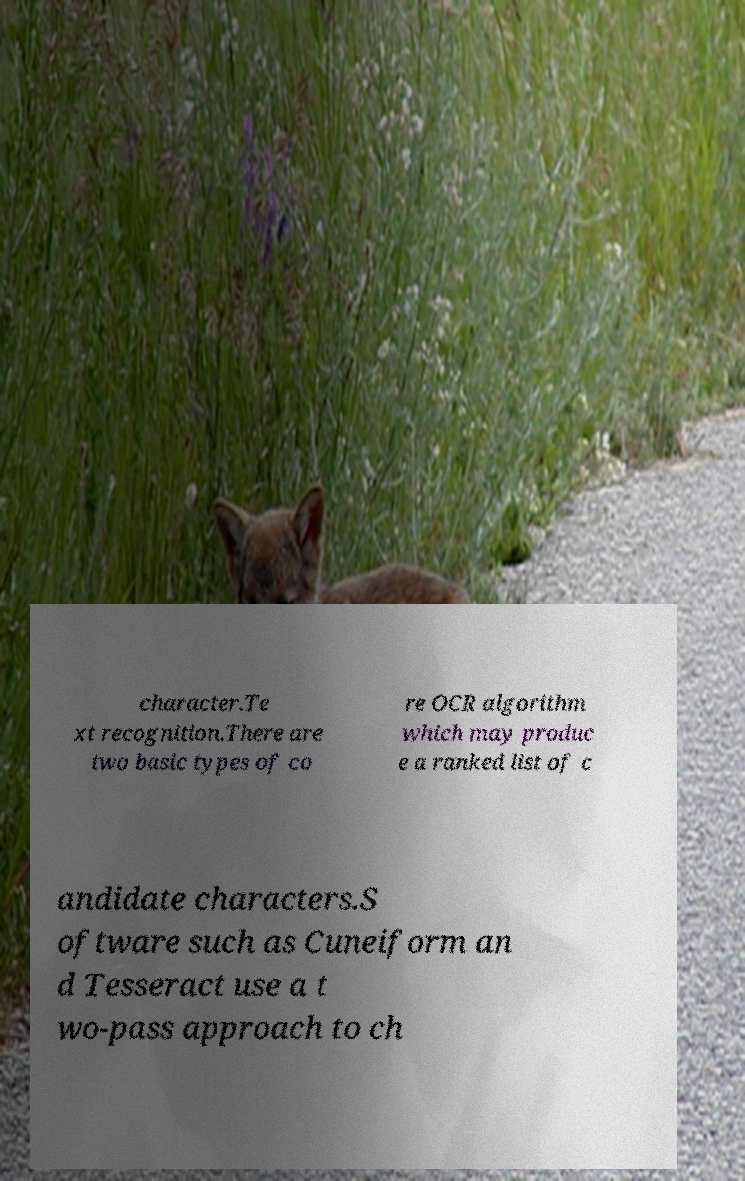I need the written content from this picture converted into text. Can you do that? character.Te xt recognition.There are two basic types of co re OCR algorithm which may produc e a ranked list of c andidate characters.S oftware such as Cuneiform an d Tesseract use a t wo-pass approach to ch 